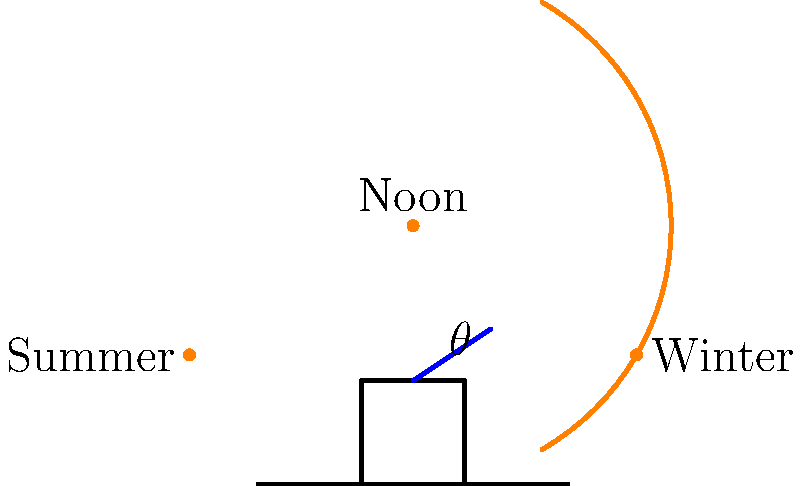As a farmer considering solar panels for your barn, you're shown this sun path diagram. What is the optimal tilt angle $\theta$ for the solar panels to maximize energy collection throughout the year? To determine the optimal tilt angle for solar panels, we need to consider the sun's path throughout the year:

1. The sun's position changes seasonally, as shown by the orange arc in the diagram.
2. In winter, the sun is lower in the sky (right side of the arc).
3. In summer, the sun is higher in the sky (left side of the arc).
4. At solar noon, the sun is at its highest point for the day (top of the arc).

The optimal tilt angle should:
a) Maximize exposure during winter when energy is needed most for heating.
b) Provide good exposure during summer for overall energy production.
c) Consider the latitude of the farm location.

A general rule of thumb for fixed solar panels is:
- Optimal tilt angle $\theta$ ≈ latitude of the location

For most farms in the continental United States, latitudes range from about 30° to 45°. Therefore, a tilt angle in this range would be suitable for year-round energy production.

The diagram shows an angle $\theta$ that appears to be approximately 30-45°, which aligns with this principle.

This angle allows for:
1. Good winter sun exposure when the sun is lower.
2. Adequate summer exposure without overheating the panels.
3. Optimal year-round energy collection.
Answer: 30-45 degrees 